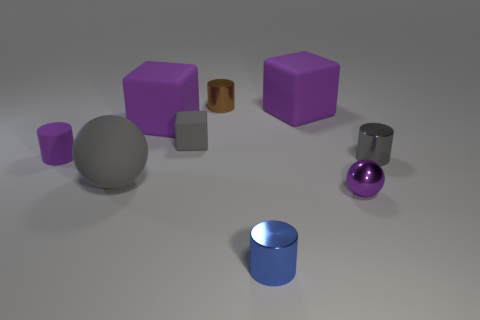There is a small cylinder that is behind the tiny matte block; what color is it?
Provide a short and direct response. Brown. There is a tiny block that is the same color as the matte sphere; what material is it?
Your response must be concise. Rubber. How many small matte cylinders are the same color as the small metal sphere?
Ensure brevity in your answer.  1. There is a matte cylinder; does it have the same size as the sphere behind the tiny purple metal object?
Your answer should be very brief. No. There is a cylinder that is on the right side of the purple object that is in front of the purple rubber cylinder that is left of the brown metal thing; how big is it?
Ensure brevity in your answer.  Small. There is a small gray cylinder; how many cylinders are behind it?
Give a very brief answer. 2. What material is the sphere to the right of the purple matte block that is to the left of the brown metallic object?
Give a very brief answer. Metal. Is there any other thing that is the same size as the gray matte cube?
Provide a short and direct response. Yes. Is the size of the gray metal thing the same as the brown cylinder?
Give a very brief answer. Yes. How many things are cylinders left of the small blue cylinder or metal things that are in front of the tiny gray matte object?
Ensure brevity in your answer.  5. 